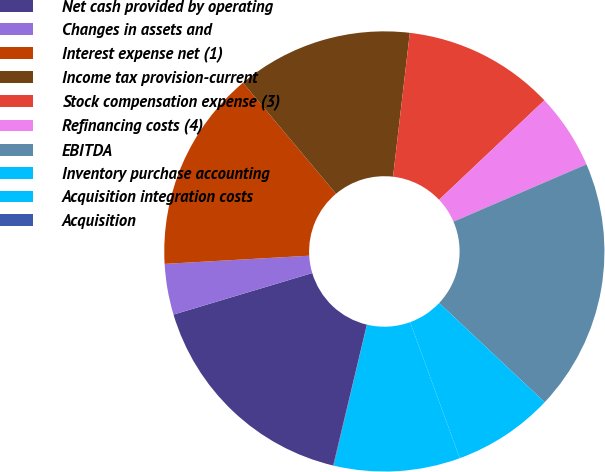Convert chart to OTSL. <chart><loc_0><loc_0><loc_500><loc_500><pie_chart><fcel>Net cash provided by operating<fcel>Changes in assets and<fcel>Interest expense net (1)<fcel>Income tax provision-current<fcel>Stock compensation expense (3)<fcel>Refinancing costs (4)<fcel>EBITDA<fcel>Inventory purchase accounting<fcel>Acquisition integration costs<fcel>Acquisition<nl><fcel>16.64%<fcel>3.73%<fcel>14.8%<fcel>12.95%<fcel>11.11%<fcel>5.57%<fcel>18.49%<fcel>7.42%<fcel>9.26%<fcel>0.04%<nl></chart> 